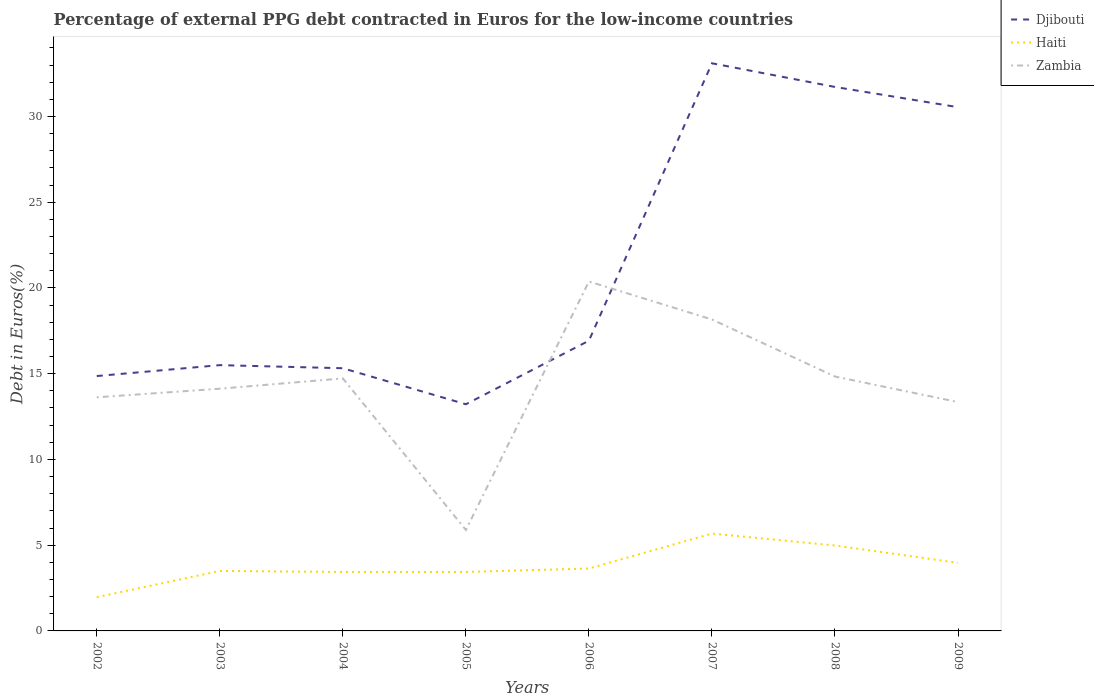How many different coloured lines are there?
Give a very brief answer. 3. Does the line corresponding to Haiti intersect with the line corresponding to Djibouti?
Give a very brief answer. No. Across all years, what is the maximum percentage of external PPG debt contracted in Euros in Zambia?
Keep it short and to the point. 5.89. In which year was the percentage of external PPG debt contracted in Euros in Djibouti maximum?
Give a very brief answer. 2005. What is the total percentage of external PPG debt contracted in Euros in Haiti in the graph?
Make the answer very short. -1.34. What is the difference between the highest and the second highest percentage of external PPG debt contracted in Euros in Djibouti?
Offer a terse response. 19.88. What is the difference between the highest and the lowest percentage of external PPG debt contracted in Euros in Haiti?
Make the answer very short. 3. Is the percentage of external PPG debt contracted in Euros in Haiti strictly greater than the percentage of external PPG debt contracted in Euros in Zambia over the years?
Provide a short and direct response. Yes. How many lines are there?
Provide a succinct answer. 3. How many years are there in the graph?
Keep it short and to the point. 8. Are the values on the major ticks of Y-axis written in scientific E-notation?
Make the answer very short. No. What is the title of the graph?
Keep it short and to the point. Percentage of external PPG debt contracted in Euros for the low-income countries. Does "West Bank and Gaza" appear as one of the legend labels in the graph?
Keep it short and to the point. No. What is the label or title of the Y-axis?
Keep it short and to the point. Debt in Euros(%). What is the Debt in Euros(%) of Djibouti in 2002?
Give a very brief answer. 14.86. What is the Debt in Euros(%) in Haiti in 2002?
Keep it short and to the point. 1.97. What is the Debt in Euros(%) in Zambia in 2002?
Offer a very short reply. 13.62. What is the Debt in Euros(%) of Djibouti in 2003?
Your response must be concise. 15.5. What is the Debt in Euros(%) of Haiti in 2003?
Ensure brevity in your answer.  3.5. What is the Debt in Euros(%) of Zambia in 2003?
Provide a succinct answer. 14.12. What is the Debt in Euros(%) of Djibouti in 2004?
Offer a terse response. 15.32. What is the Debt in Euros(%) of Haiti in 2004?
Your answer should be compact. 3.44. What is the Debt in Euros(%) in Zambia in 2004?
Make the answer very short. 14.72. What is the Debt in Euros(%) in Djibouti in 2005?
Your response must be concise. 13.22. What is the Debt in Euros(%) in Haiti in 2005?
Keep it short and to the point. 3.44. What is the Debt in Euros(%) in Zambia in 2005?
Make the answer very short. 5.89. What is the Debt in Euros(%) in Djibouti in 2006?
Provide a succinct answer. 16.92. What is the Debt in Euros(%) in Haiti in 2006?
Ensure brevity in your answer.  3.64. What is the Debt in Euros(%) of Zambia in 2006?
Your answer should be very brief. 20.38. What is the Debt in Euros(%) of Djibouti in 2007?
Offer a very short reply. 33.1. What is the Debt in Euros(%) of Haiti in 2007?
Your answer should be compact. 5.68. What is the Debt in Euros(%) in Zambia in 2007?
Provide a short and direct response. 18.16. What is the Debt in Euros(%) of Djibouti in 2008?
Your response must be concise. 31.72. What is the Debt in Euros(%) of Haiti in 2008?
Keep it short and to the point. 4.98. What is the Debt in Euros(%) of Zambia in 2008?
Your answer should be very brief. 14.83. What is the Debt in Euros(%) of Djibouti in 2009?
Your answer should be very brief. 30.54. What is the Debt in Euros(%) in Haiti in 2009?
Keep it short and to the point. 3.97. What is the Debt in Euros(%) in Zambia in 2009?
Offer a very short reply. 13.35. Across all years, what is the maximum Debt in Euros(%) in Djibouti?
Provide a succinct answer. 33.1. Across all years, what is the maximum Debt in Euros(%) in Haiti?
Offer a very short reply. 5.68. Across all years, what is the maximum Debt in Euros(%) of Zambia?
Offer a terse response. 20.38. Across all years, what is the minimum Debt in Euros(%) in Djibouti?
Make the answer very short. 13.22. Across all years, what is the minimum Debt in Euros(%) of Haiti?
Offer a terse response. 1.97. Across all years, what is the minimum Debt in Euros(%) of Zambia?
Provide a succinct answer. 5.89. What is the total Debt in Euros(%) of Djibouti in the graph?
Ensure brevity in your answer.  171.18. What is the total Debt in Euros(%) in Haiti in the graph?
Your answer should be very brief. 30.61. What is the total Debt in Euros(%) in Zambia in the graph?
Offer a very short reply. 115.07. What is the difference between the Debt in Euros(%) in Djibouti in 2002 and that in 2003?
Ensure brevity in your answer.  -0.64. What is the difference between the Debt in Euros(%) in Haiti in 2002 and that in 2003?
Provide a short and direct response. -1.53. What is the difference between the Debt in Euros(%) in Zambia in 2002 and that in 2003?
Make the answer very short. -0.5. What is the difference between the Debt in Euros(%) of Djibouti in 2002 and that in 2004?
Your answer should be very brief. -0.46. What is the difference between the Debt in Euros(%) of Haiti in 2002 and that in 2004?
Offer a very short reply. -1.47. What is the difference between the Debt in Euros(%) in Zambia in 2002 and that in 2004?
Make the answer very short. -1.1. What is the difference between the Debt in Euros(%) of Djibouti in 2002 and that in 2005?
Your answer should be very brief. 1.64. What is the difference between the Debt in Euros(%) in Haiti in 2002 and that in 2005?
Ensure brevity in your answer.  -1.47. What is the difference between the Debt in Euros(%) of Zambia in 2002 and that in 2005?
Keep it short and to the point. 7.73. What is the difference between the Debt in Euros(%) in Djibouti in 2002 and that in 2006?
Offer a very short reply. -2.06. What is the difference between the Debt in Euros(%) of Haiti in 2002 and that in 2006?
Ensure brevity in your answer.  -1.67. What is the difference between the Debt in Euros(%) in Zambia in 2002 and that in 2006?
Give a very brief answer. -6.75. What is the difference between the Debt in Euros(%) in Djibouti in 2002 and that in 2007?
Make the answer very short. -18.24. What is the difference between the Debt in Euros(%) of Haiti in 2002 and that in 2007?
Keep it short and to the point. -3.71. What is the difference between the Debt in Euros(%) in Zambia in 2002 and that in 2007?
Ensure brevity in your answer.  -4.54. What is the difference between the Debt in Euros(%) of Djibouti in 2002 and that in 2008?
Ensure brevity in your answer.  -16.86. What is the difference between the Debt in Euros(%) of Haiti in 2002 and that in 2008?
Keep it short and to the point. -3.02. What is the difference between the Debt in Euros(%) in Zambia in 2002 and that in 2008?
Your answer should be compact. -1.21. What is the difference between the Debt in Euros(%) in Djibouti in 2002 and that in 2009?
Provide a short and direct response. -15.68. What is the difference between the Debt in Euros(%) of Haiti in 2002 and that in 2009?
Ensure brevity in your answer.  -2. What is the difference between the Debt in Euros(%) of Zambia in 2002 and that in 2009?
Provide a succinct answer. 0.28. What is the difference between the Debt in Euros(%) of Djibouti in 2003 and that in 2004?
Offer a very short reply. 0.18. What is the difference between the Debt in Euros(%) in Haiti in 2003 and that in 2004?
Make the answer very short. 0.06. What is the difference between the Debt in Euros(%) in Zambia in 2003 and that in 2004?
Offer a terse response. -0.6. What is the difference between the Debt in Euros(%) in Djibouti in 2003 and that in 2005?
Keep it short and to the point. 2.28. What is the difference between the Debt in Euros(%) in Haiti in 2003 and that in 2005?
Offer a terse response. 0.06. What is the difference between the Debt in Euros(%) of Zambia in 2003 and that in 2005?
Offer a terse response. 8.24. What is the difference between the Debt in Euros(%) in Djibouti in 2003 and that in 2006?
Give a very brief answer. -1.43. What is the difference between the Debt in Euros(%) of Haiti in 2003 and that in 2006?
Your response must be concise. -0.14. What is the difference between the Debt in Euros(%) in Zambia in 2003 and that in 2006?
Your response must be concise. -6.25. What is the difference between the Debt in Euros(%) in Djibouti in 2003 and that in 2007?
Ensure brevity in your answer.  -17.6. What is the difference between the Debt in Euros(%) of Haiti in 2003 and that in 2007?
Offer a very short reply. -2.18. What is the difference between the Debt in Euros(%) of Zambia in 2003 and that in 2007?
Provide a succinct answer. -4.04. What is the difference between the Debt in Euros(%) of Djibouti in 2003 and that in 2008?
Your answer should be compact. -16.22. What is the difference between the Debt in Euros(%) in Haiti in 2003 and that in 2008?
Your answer should be compact. -1.49. What is the difference between the Debt in Euros(%) of Zambia in 2003 and that in 2008?
Your answer should be very brief. -0.71. What is the difference between the Debt in Euros(%) of Djibouti in 2003 and that in 2009?
Provide a succinct answer. -15.04. What is the difference between the Debt in Euros(%) of Haiti in 2003 and that in 2009?
Your response must be concise. -0.47. What is the difference between the Debt in Euros(%) of Zambia in 2003 and that in 2009?
Ensure brevity in your answer.  0.78. What is the difference between the Debt in Euros(%) in Djibouti in 2004 and that in 2005?
Provide a short and direct response. 2.1. What is the difference between the Debt in Euros(%) of Zambia in 2004 and that in 2005?
Make the answer very short. 8.84. What is the difference between the Debt in Euros(%) of Djibouti in 2004 and that in 2006?
Provide a succinct answer. -1.61. What is the difference between the Debt in Euros(%) in Haiti in 2004 and that in 2006?
Offer a terse response. -0.2. What is the difference between the Debt in Euros(%) in Zambia in 2004 and that in 2006?
Make the answer very short. -5.65. What is the difference between the Debt in Euros(%) of Djibouti in 2004 and that in 2007?
Give a very brief answer. -17.78. What is the difference between the Debt in Euros(%) of Haiti in 2004 and that in 2007?
Provide a succinct answer. -2.24. What is the difference between the Debt in Euros(%) in Zambia in 2004 and that in 2007?
Your answer should be very brief. -3.44. What is the difference between the Debt in Euros(%) in Djibouti in 2004 and that in 2008?
Your answer should be very brief. -16.4. What is the difference between the Debt in Euros(%) in Haiti in 2004 and that in 2008?
Keep it short and to the point. -1.54. What is the difference between the Debt in Euros(%) of Zambia in 2004 and that in 2008?
Keep it short and to the point. -0.11. What is the difference between the Debt in Euros(%) in Djibouti in 2004 and that in 2009?
Your response must be concise. -15.22. What is the difference between the Debt in Euros(%) of Haiti in 2004 and that in 2009?
Your response must be concise. -0.53. What is the difference between the Debt in Euros(%) of Zambia in 2004 and that in 2009?
Make the answer very short. 1.38. What is the difference between the Debt in Euros(%) in Djibouti in 2005 and that in 2006?
Provide a succinct answer. -3.71. What is the difference between the Debt in Euros(%) of Haiti in 2005 and that in 2006?
Ensure brevity in your answer.  -0.2. What is the difference between the Debt in Euros(%) of Zambia in 2005 and that in 2006?
Give a very brief answer. -14.49. What is the difference between the Debt in Euros(%) of Djibouti in 2005 and that in 2007?
Offer a very short reply. -19.88. What is the difference between the Debt in Euros(%) of Haiti in 2005 and that in 2007?
Your answer should be very brief. -2.24. What is the difference between the Debt in Euros(%) in Zambia in 2005 and that in 2007?
Offer a very short reply. -12.27. What is the difference between the Debt in Euros(%) in Djibouti in 2005 and that in 2008?
Provide a succinct answer. -18.5. What is the difference between the Debt in Euros(%) in Haiti in 2005 and that in 2008?
Your response must be concise. -1.54. What is the difference between the Debt in Euros(%) of Zambia in 2005 and that in 2008?
Offer a very short reply. -8.95. What is the difference between the Debt in Euros(%) of Djibouti in 2005 and that in 2009?
Provide a succinct answer. -17.32. What is the difference between the Debt in Euros(%) of Haiti in 2005 and that in 2009?
Provide a short and direct response. -0.53. What is the difference between the Debt in Euros(%) in Zambia in 2005 and that in 2009?
Keep it short and to the point. -7.46. What is the difference between the Debt in Euros(%) of Djibouti in 2006 and that in 2007?
Provide a succinct answer. -16.18. What is the difference between the Debt in Euros(%) of Haiti in 2006 and that in 2007?
Offer a terse response. -2.04. What is the difference between the Debt in Euros(%) in Zambia in 2006 and that in 2007?
Keep it short and to the point. 2.21. What is the difference between the Debt in Euros(%) in Djibouti in 2006 and that in 2008?
Your answer should be compact. -14.8. What is the difference between the Debt in Euros(%) in Haiti in 2006 and that in 2008?
Provide a succinct answer. -1.34. What is the difference between the Debt in Euros(%) of Zambia in 2006 and that in 2008?
Ensure brevity in your answer.  5.54. What is the difference between the Debt in Euros(%) in Djibouti in 2006 and that in 2009?
Make the answer very short. -13.62. What is the difference between the Debt in Euros(%) in Haiti in 2006 and that in 2009?
Give a very brief answer. -0.33. What is the difference between the Debt in Euros(%) of Zambia in 2006 and that in 2009?
Your response must be concise. 7.03. What is the difference between the Debt in Euros(%) in Djibouti in 2007 and that in 2008?
Your response must be concise. 1.38. What is the difference between the Debt in Euros(%) in Haiti in 2007 and that in 2008?
Offer a terse response. 0.69. What is the difference between the Debt in Euros(%) in Zambia in 2007 and that in 2008?
Ensure brevity in your answer.  3.33. What is the difference between the Debt in Euros(%) of Djibouti in 2007 and that in 2009?
Give a very brief answer. 2.56. What is the difference between the Debt in Euros(%) in Haiti in 2007 and that in 2009?
Your answer should be compact. 1.71. What is the difference between the Debt in Euros(%) in Zambia in 2007 and that in 2009?
Provide a succinct answer. 4.82. What is the difference between the Debt in Euros(%) of Djibouti in 2008 and that in 2009?
Offer a terse response. 1.18. What is the difference between the Debt in Euros(%) of Haiti in 2008 and that in 2009?
Keep it short and to the point. 1.01. What is the difference between the Debt in Euros(%) of Zambia in 2008 and that in 2009?
Provide a short and direct response. 1.49. What is the difference between the Debt in Euros(%) in Djibouti in 2002 and the Debt in Euros(%) in Haiti in 2003?
Provide a short and direct response. 11.37. What is the difference between the Debt in Euros(%) of Djibouti in 2002 and the Debt in Euros(%) of Zambia in 2003?
Make the answer very short. 0.74. What is the difference between the Debt in Euros(%) of Haiti in 2002 and the Debt in Euros(%) of Zambia in 2003?
Make the answer very short. -12.16. What is the difference between the Debt in Euros(%) in Djibouti in 2002 and the Debt in Euros(%) in Haiti in 2004?
Provide a succinct answer. 11.42. What is the difference between the Debt in Euros(%) in Djibouti in 2002 and the Debt in Euros(%) in Zambia in 2004?
Keep it short and to the point. 0.14. What is the difference between the Debt in Euros(%) in Haiti in 2002 and the Debt in Euros(%) in Zambia in 2004?
Offer a very short reply. -12.76. What is the difference between the Debt in Euros(%) of Djibouti in 2002 and the Debt in Euros(%) of Haiti in 2005?
Your answer should be compact. 11.42. What is the difference between the Debt in Euros(%) of Djibouti in 2002 and the Debt in Euros(%) of Zambia in 2005?
Your response must be concise. 8.97. What is the difference between the Debt in Euros(%) in Haiti in 2002 and the Debt in Euros(%) in Zambia in 2005?
Offer a terse response. -3.92. What is the difference between the Debt in Euros(%) of Djibouti in 2002 and the Debt in Euros(%) of Haiti in 2006?
Your response must be concise. 11.22. What is the difference between the Debt in Euros(%) in Djibouti in 2002 and the Debt in Euros(%) in Zambia in 2006?
Provide a short and direct response. -5.51. What is the difference between the Debt in Euros(%) of Haiti in 2002 and the Debt in Euros(%) of Zambia in 2006?
Offer a terse response. -18.41. What is the difference between the Debt in Euros(%) in Djibouti in 2002 and the Debt in Euros(%) in Haiti in 2007?
Offer a very short reply. 9.19. What is the difference between the Debt in Euros(%) of Djibouti in 2002 and the Debt in Euros(%) of Zambia in 2007?
Your answer should be compact. -3.3. What is the difference between the Debt in Euros(%) of Haiti in 2002 and the Debt in Euros(%) of Zambia in 2007?
Your answer should be compact. -16.19. What is the difference between the Debt in Euros(%) of Djibouti in 2002 and the Debt in Euros(%) of Haiti in 2008?
Give a very brief answer. 9.88. What is the difference between the Debt in Euros(%) of Djibouti in 2002 and the Debt in Euros(%) of Zambia in 2008?
Your answer should be very brief. 0.03. What is the difference between the Debt in Euros(%) of Haiti in 2002 and the Debt in Euros(%) of Zambia in 2008?
Ensure brevity in your answer.  -12.87. What is the difference between the Debt in Euros(%) in Djibouti in 2002 and the Debt in Euros(%) in Haiti in 2009?
Keep it short and to the point. 10.89. What is the difference between the Debt in Euros(%) in Djibouti in 2002 and the Debt in Euros(%) in Zambia in 2009?
Provide a succinct answer. 1.52. What is the difference between the Debt in Euros(%) of Haiti in 2002 and the Debt in Euros(%) of Zambia in 2009?
Ensure brevity in your answer.  -11.38. What is the difference between the Debt in Euros(%) in Djibouti in 2003 and the Debt in Euros(%) in Haiti in 2004?
Your answer should be compact. 12.06. What is the difference between the Debt in Euros(%) of Djibouti in 2003 and the Debt in Euros(%) of Zambia in 2004?
Make the answer very short. 0.77. What is the difference between the Debt in Euros(%) of Haiti in 2003 and the Debt in Euros(%) of Zambia in 2004?
Ensure brevity in your answer.  -11.23. What is the difference between the Debt in Euros(%) in Djibouti in 2003 and the Debt in Euros(%) in Haiti in 2005?
Keep it short and to the point. 12.06. What is the difference between the Debt in Euros(%) in Djibouti in 2003 and the Debt in Euros(%) in Zambia in 2005?
Provide a succinct answer. 9.61. What is the difference between the Debt in Euros(%) of Haiti in 2003 and the Debt in Euros(%) of Zambia in 2005?
Your answer should be compact. -2.39. What is the difference between the Debt in Euros(%) of Djibouti in 2003 and the Debt in Euros(%) of Haiti in 2006?
Provide a succinct answer. 11.86. What is the difference between the Debt in Euros(%) of Djibouti in 2003 and the Debt in Euros(%) of Zambia in 2006?
Provide a short and direct response. -4.88. What is the difference between the Debt in Euros(%) of Haiti in 2003 and the Debt in Euros(%) of Zambia in 2006?
Your answer should be very brief. -16.88. What is the difference between the Debt in Euros(%) of Djibouti in 2003 and the Debt in Euros(%) of Haiti in 2007?
Your response must be concise. 9.82. What is the difference between the Debt in Euros(%) of Djibouti in 2003 and the Debt in Euros(%) of Zambia in 2007?
Offer a very short reply. -2.66. What is the difference between the Debt in Euros(%) in Haiti in 2003 and the Debt in Euros(%) in Zambia in 2007?
Offer a very short reply. -14.66. What is the difference between the Debt in Euros(%) in Djibouti in 2003 and the Debt in Euros(%) in Haiti in 2008?
Give a very brief answer. 10.52. What is the difference between the Debt in Euros(%) of Djibouti in 2003 and the Debt in Euros(%) of Zambia in 2008?
Ensure brevity in your answer.  0.67. What is the difference between the Debt in Euros(%) in Haiti in 2003 and the Debt in Euros(%) in Zambia in 2008?
Make the answer very short. -11.34. What is the difference between the Debt in Euros(%) of Djibouti in 2003 and the Debt in Euros(%) of Haiti in 2009?
Keep it short and to the point. 11.53. What is the difference between the Debt in Euros(%) in Djibouti in 2003 and the Debt in Euros(%) in Zambia in 2009?
Offer a very short reply. 2.15. What is the difference between the Debt in Euros(%) in Haiti in 2003 and the Debt in Euros(%) in Zambia in 2009?
Your response must be concise. -9.85. What is the difference between the Debt in Euros(%) in Djibouti in 2004 and the Debt in Euros(%) in Haiti in 2005?
Offer a terse response. 11.88. What is the difference between the Debt in Euros(%) of Djibouti in 2004 and the Debt in Euros(%) of Zambia in 2005?
Give a very brief answer. 9.43. What is the difference between the Debt in Euros(%) of Haiti in 2004 and the Debt in Euros(%) of Zambia in 2005?
Ensure brevity in your answer.  -2.45. What is the difference between the Debt in Euros(%) in Djibouti in 2004 and the Debt in Euros(%) in Haiti in 2006?
Your response must be concise. 11.68. What is the difference between the Debt in Euros(%) in Djibouti in 2004 and the Debt in Euros(%) in Zambia in 2006?
Offer a very short reply. -5.06. What is the difference between the Debt in Euros(%) in Haiti in 2004 and the Debt in Euros(%) in Zambia in 2006?
Keep it short and to the point. -16.94. What is the difference between the Debt in Euros(%) in Djibouti in 2004 and the Debt in Euros(%) in Haiti in 2007?
Offer a very short reply. 9.64. What is the difference between the Debt in Euros(%) in Djibouti in 2004 and the Debt in Euros(%) in Zambia in 2007?
Provide a succinct answer. -2.84. What is the difference between the Debt in Euros(%) in Haiti in 2004 and the Debt in Euros(%) in Zambia in 2007?
Provide a short and direct response. -14.72. What is the difference between the Debt in Euros(%) of Djibouti in 2004 and the Debt in Euros(%) of Haiti in 2008?
Give a very brief answer. 10.34. What is the difference between the Debt in Euros(%) in Djibouti in 2004 and the Debt in Euros(%) in Zambia in 2008?
Provide a short and direct response. 0.48. What is the difference between the Debt in Euros(%) in Haiti in 2004 and the Debt in Euros(%) in Zambia in 2008?
Provide a succinct answer. -11.4. What is the difference between the Debt in Euros(%) in Djibouti in 2004 and the Debt in Euros(%) in Haiti in 2009?
Give a very brief answer. 11.35. What is the difference between the Debt in Euros(%) in Djibouti in 2004 and the Debt in Euros(%) in Zambia in 2009?
Offer a terse response. 1.97. What is the difference between the Debt in Euros(%) in Haiti in 2004 and the Debt in Euros(%) in Zambia in 2009?
Your answer should be very brief. -9.91. What is the difference between the Debt in Euros(%) in Djibouti in 2005 and the Debt in Euros(%) in Haiti in 2006?
Offer a terse response. 9.58. What is the difference between the Debt in Euros(%) in Djibouti in 2005 and the Debt in Euros(%) in Zambia in 2006?
Your answer should be very brief. -7.16. What is the difference between the Debt in Euros(%) of Haiti in 2005 and the Debt in Euros(%) of Zambia in 2006?
Your response must be concise. -16.94. What is the difference between the Debt in Euros(%) of Djibouti in 2005 and the Debt in Euros(%) of Haiti in 2007?
Your response must be concise. 7.54. What is the difference between the Debt in Euros(%) of Djibouti in 2005 and the Debt in Euros(%) of Zambia in 2007?
Provide a short and direct response. -4.94. What is the difference between the Debt in Euros(%) of Haiti in 2005 and the Debt in Euros(%) of Zambia in 2007?
Your response must be concise. -14.72. What is the difference between the Debt in Euros(%) of Djibouti in 2005 and the Debt in Euros(%) of Haiti in 2008?
Your answer should be very brief. 8.23. What is the difference between the Debt in Euros(%) in Djibouti in 2005 and the Debt in Euros(%) in Zambia in 2008?
Offer a terse response. -1.62. What is the difference between the Debt in Euros(%) in Haiti in 2005 and the Debt in Euros(%) in Zambia in 2008?
Give a very brief answer. -11.4. What is the difference between the Debt in Euros(%) in Djibouti in 2005 and the Debt in Euros(%) in Haiti in 2009?
Give a very brief answer. 9.25. What is the difference between the Debt in Euros(%) in Djibouti in 2005 and the Debt in Euros(%) in Zambia in 2009?
Make the answer very short. -0.13. What is the difference between the Debt in Euros(%) of Haiti in 2005 and the Debt in Euros(%) of Zambia in 2009?
Your response must be concise. -9.91. What is the difference between the Debt in Euros(%) in Djibouti in 2006 and the Debt in Euros(%) in Haiti in 2007?
Offer a terse response. 11.25. What is the difference between the Debt in Euros(%) in Djibouti in 2006 and the Debt in Euros(%) in Zambia in 2007?
Offer a very short reply. -1.24. What is the difference between the Debt in Euros(%) of Haiti in 2006 and the Debt in Euros(%) of Zambia in 2007?
Give a very brief answer. -14.52. What is the difference between the Debt in Euros(%) in Djibouti in 2006 and the Debt in Euros(%) in Haiti in 2008?
Give a very brief answer. 11.94. What is the difference between the Debt in Euros(%) of Djibouti in 2006 and the Debt in Euros(%) of Zambia in 2008?
Make the answer very short. 2.09. What is the difference between the Debt in Euros(%) in Haiti in 2006 and the Debt in Euros(%) in Zambia in 2008?
Provide a succinct answer. -11.19. What is the difference between the Debt in Euros(%) of Djibouti in 2006 and the Debt in Euros(%) of Haiti in 2009?
Your response must be concise. 12.96. What is the difference between the Debt in Euros(%) in Djibouti in 2006 and the Debt in Euros(%) in Zambia in 2009?
Give a very brief answer. 3.58. What is the difference between the Debt in Euros(%) of Haiti in 2006 and the Debt in Euros(%) of Zambia in 2009?
Make the answer very short. -9.71. What is the difference between the Debt in Euros(%) of Djibouti in 2007 and the Debt in Euros(%) of Haiti in 2008?
Provide a succinct answer. 28.12. What is the difference between the Debt in Euros(%) in Djibouti in 2007 and the Debt in Euros(%) in Zambia in 2008?
Your answer should be very brief. 18.27. What is the difference between the Debt in Euros(%) in Haiti in 2007 and the Debt in Euros(%) in Zambia in 2008?
Give a very brief answer. -9.16. What is the difference between the Debt in Euros(%) in Djibouti in 2007 and the Debt in Euros(%) in Haiti in 2009?
Provide a short and direct response. 29.13. What is the difference between the Debt in Euros(%) of Djibouti in 2007 and the Debt in Euros(%) of Zambia in 2009?
Keep it short and to the point. 19.76. What is the difference between the Debt in Euros(%) in Haiti in 2007 and the Debt in Euros(%) in Zambia in 2009?
Your answer should be very brief. -7.67. What is the difference between the Debt in Euros(%) of Djibouti in 2008 and the Debt in Euros(%) of Haiti in 2009?
Ensure brevity in your answer.  27.75. What is the difference between the Debt in Euros(%) of Djibouti in 2008 and the Debt in Euros(%) of Zambia in 2009?
Provide a short and direct response. 18.38. What is the difference between the Debt in Euros(%) in Haiti in 2008 and the Debt in Euros(%) in Zambia in 2009?
Offer a terse response. -8.36. What is the average Debt in Euros(%) of Djibouti per year?
Keep it short and to the point. 21.4. What is the average Debt in Euros(%) of Haiti per year?
Ensure brevity in your answer.  3.83. What is the average Debt in Euros(%) in Zambia per year?
Your answer should be very brief. 14.38. In the year 2002, what is the difference between the Debt in Euros(%) in Djibouti and Debt in Euros(%) in Haiti?
Make the answer very short. 12.9. In the year 2002, what is the difference between the Debt in Euros(%) of Djibouti and Debt in Euros(%) of Zambia?
Your answer should be very brief. 1.24. In the year 2002, what is the difference between the Debt in Euros(%) of Haiti and Debt in Euros(%) of Zambia?
Your answer should be very brief. -11.66. In the year 2003, what is the difference between the Debt in Euros(%) in Djibouti and Debt in Euros(%) in Haiti?
Your answer should be compact. 12. In the year 2003, what is the difference between the Debt in Euros(%) of Djibouti and Debt in Euros(%) of Zambia?
Ensure brevity in your answer.  1.37. In the year 2003, what is the difference between the Debt in Euros(%) of Haiti and Debt in Euros(%) of Zambia?
Offer a terse response. -10.63. In the year 2004, what is the difference between the Debt in Euros(%) in Djibouti and Debt in Euros(%) in Haiti?
Offer a terse response. 11.88. In the year 2004, what is the difference between the Debt in Euros(%) in Djibouti and Debt in Euros(%) in Zambia?
Make the answer very short. 0.59. In the year 2004, what is the difference between the Debt in Euros(%) of Haiti and Debt in Euros(%) of Zambia?
Offer a terse response. -11.29. In the year 2005, what is the difference between the Debt in Euros(%) of Djibouti and Debt in Euros(%) of Haiti?
Your answer should be very brief. 9.78. In the year 2005, what is the difference between the Debt in Euros(%) in Djibouti and Debt in Euros(%) in Zambia?
Your answer should be compact. 7.33. In the year 2005, what is the difference between the Debt in Euros(%) of Haiti and Debt in Euros(%) of Zambia?
Your answer should be very brief. -2.45. In the year 2006, what is the difference between the Debt in Euros(%) of Djibouti and Debt in Euros(%) of Haiti?
Your answer should be very brief. 13.28. In the year 2006, what is the difference between the Debt in Euros(%) in Djibouti and Debt in Euros(%) in Zambia?
Your answer should be compact. -3.45. In the year 2006, what is the difference between the Debt in Euros(%) of Haiti and Debt in Euros(%) of Zambia?
Provide a short and direct response. -16.74. In the year 2007, what is the difference between the Debt in Euros(%) in Djibouti and Debt in Euros(%) in Haiti?
Give a very brief answer. 27.42. In the year 2007, what is the difference between the Debt in Euros(%) in Djibouti and Debt in Euros(%) in Zambia?
Your response must be concise. 14.94. In the year 2007, what is the difference between the Debt in Euros(%) in Haiti and Debt in Euros(%) in Zambia?
Provide a succinct answer. -12.48. In the year 2008, what is the difference between the Debt in Euros(%) in Djibouti and Debt in Euros(%) in Haiti?
Offer a terse response. 26.74. In the year 2008, what is the difference between the Debt in Euros(%) in Djibouti and Debt in Euros(%) in Zambia?
Provide a succinct answer. 16.89. In the year 2008, what is the difference between the Debt in Euros(%) of Haiti and Debt in Euros(%) of Zambia?
Your response must be concise. -9.85. In the year 2009, what is the difference between the Debt in Euros(%) of Djibouti and Debt in Euros(%) of Haiti?
Give a very brief answer. 26.57. In the year 2009, what is the difference between the Debt in Euros(%) of Djibouti and Debt in Euros(%) of Zambia?
Offer a terse response. 17.19. In the year 2009, what is the difference between the Debt in Euros(%) of Haiti and Debt in Euros(%) of Zambia?
Offer a terse response. -9.38. What is the ratio of the Debt in Euros(%) in Djibouti in 2002 to that in 2003?
Make the answer very short. 0.96. What is the ratio of the Debt in Euros(%) of Haiti in 2002 to that in 2003?
Offer a very short reply. 0.56. What is the ratio of the Debt in Euros(%) of Zambia in 2002 to that in 2003?
Your answer should be very brief. 0.96. What is the ratio of the Debt in Euros(%) of Djibouti in 2002 to that in 2004?
Make the answer very short. 0.97. What is the ratio of the Debt in Euros(%) in Haiti in 2002 to that in 2004?
Give a very brief answer. 0.57. What is the ratio of the Debt in Euros(%) in Zambia in 2002 to that in 2004?
Your response must be concise. 0.93. What is the ratio of the Debt in Euros(%) of Djibouti in 2002 to that in 2005?
Offer a very short reply. 1.12. What is the ratio of the Debt in Euros(%) in Haiti in 2002 to that in 2005?
Provide a short and direct response. 0.57. What is the ratio of the Debt in Euros(%) of Zambia in 2002 to that in 2005?
Provide a short and direct response. 2.31. What is the ratio of the Debt in Euros(%) of Djibouti in 2002 to that in 2006?
Offer a very short reply. 0.88. What is the ratio of the Debt in Euros(%) in Haiti in 2002 to that in 2006?
Offer a terse response. 0.54. What is the ratio of the Debt in Euros(%) of Zambia in 2002 to that in 2006?
Ensure brevity in your answer.  0.67. What is the ratio of the Debt in Euros(%) in Djibouti in 2002 to that in 2007?
Give a very brief answer. 0.45. What is the ratio of the Debt in Euros(%) in Haiti in 2002 to that in 2007?
Make the answer very short. 0.35. What is the ratio of the Debt in Euros(%) of Zambia in 2002 to that in 2007?
Make the answer very short. 0.75. What is the ratio of the Debt in Euros(%) in Djibouti in 2002 to that in 2008?
Provide a short and direct response. 0.47. What is the ratio of the Debt in Euros(%) in Haiti in 2002 to that in 2008?
Keep it short and to the point. 0.39. What is the ratio of the Debt in Euros(%) of Zambia in 2002 to that in 2008?
Keep it short and to the point. 0.92. What is the ratio of the Debt in Euros(%) of Djibouti in 2002 to that in 2009?
Your answer should be compact. 0.49. What is the ratio of the Debt in Euros(%) of Haiti in 2002 to that in 2009?
Provide a succinct answer. 0.5. What is the ratio of the Debt in Euros(%) in Zambia in 2002 to that in 2009?
Offer a very short reply. 1.02. What is the ratio of the Debt in Euros(%) in Djibouti in 2003 to that in 2004?
Your response must be concise. 1.01. What is the ratio of the Debt in Euros(%) in Haiti in 2003 to that in 2004?
Keep it short and to the point. 1.02. What is the ratio of the Debt in Euros(%) in Zambia in 2003 to that in 2004?
Your response must be concise. 0.96. What is the ratio of the Debt in Euros(%) of Djibouti in 2003 to that in 2005?
Ensure brevity in your answer.  1.17. What is the ratio of the Debt in Euros(%) in Haiti in 2003 to that in 2005?
Provide a short and direct response. 1.02. What is the ratio of the Debt in Euros(%) of Zambia in 2003 to that in 2005?
Keep it short and to the point. 2.4. What is the ratio of the Debt in Euros(%) in Djibouti in 2003 to that in 2006?
Provide a succinct answer. 0.92. What is the ratio of the Debt in Euros(%) of Haiti in 2003 to that in 2006?
Provide a succinct answer. 0.96. What is the ratio of the Debt in Euros(%) of Zambia in 2003 to that in 2006?
Your response must be concise. 0.69. What is the ratio of the Debt in Euros(%) of Djibouti in 2003 to that in 2007?
Provide a succinct answer. 0.47. What is the ratio of the Debt in Euros(%) of Haiti in 2003 to that in 2007?
Keep it short and to the point. 0.62. What is the ratio of the Debt in Euros(%) of Zambia in 2003 to that in 2007?
Make the answer very short. 0.78. What is the ratio of the Debt in Euros(%) in Djibouti in 2003 to that in 2008?
Your answer should be very brief. 0.49. What is the ratio of the Debt in Euros(%) in Haiti in 2003 to that in 2008?
Give a very brief answer. 0.7. What is the ratio of the Debt in Euros(%) of Zambia in 2003 to that in 2008?
Give a very brief answer. 0.95. What is the ratio of the Debt in Euros(%) of Djibouti in 2003 to that in 2009?
Your response must be concise. 0.51. What is the ratio of the Debt in Euros(%) of Haiti in 2003 to that in 2009?
Your answer should be compact. 0.88. What is the ratio of the Debt in Euros(%) in Zambia in 2003 to that in 2009?
Offer a very short reply. 1.06. What is the ratio of the Debt in Euros(%) of Djibouti in 2004 to that in 2005?
Ensure brevity in your answer.  1.16. What is the ratio of the Debt in Euros(%) of Zambia in 2004 to that in 2005?
Your answer should be very brief. 2.5. What is the ratio of the Debt in Euros(%) of Djibouti in 2004 to that in 2006?
Give a very brief answer. 0.91. What is the ratio of the Debt in Euros(%) of Haiti in 2004 to that in 2006?
Offer a very short reply. 0.94. What is the ratio of the Debt in Euros(%) of Zambia in 2004 to that in 2006?
Your answer should be compact. 0.72. What is the ratio of the Debt in Euros(%) of Djibouti in 2004 to that in 2007?
Give a very brief answer. 0.46. What is the ratio of the Debt in Euros(%) of Haiti in 2004 to that in 2007?
Your response must be concise. 0.61. What is the ratio of the Debt in Euros(%) in Zambia in 2004 to that in 2007?
Provide a short and direct response. 0.81. What is the ratio of the Debt in Euros(%) of Djibouti in 2004 to that in 2008?
Ensure brevity in your answer.  0.48. What is the ratio of the Debt in Euros(%) in Haiti in 2004 to that in 2008?
Offer a very short reply. 0.69. What is the ratio of the Debt in Euros(%) in Zambia in 2004 to that in 2008?
Provide a succinct answer. 0.99. What is the ratio of the Debt in Euros(%) in Djibouti in 2004 to that in 2009?
Your answer should be very brief. 0.5. What is the ratio of the Debt in Euros(%) of Haiti in 2004 to that in 2009?
Keep it short and to the point. 0.87. What is the ratio of the Debt in Euros(%) of Zambia in 2004 to that in 2009?
Your answer should be very brief. 1.1. What is the ratio of the Debt in Euros(%) of Djibouti in 2005 to that in 2006?
Give a very brief answer. 0.78. What is the ratio of the Debt in Euros(%) of Haiti in 2005 to that in 2006?
Your answer should be compact. 0.94. What is the ratio of the Debt in Euros(%) in Zambia in 2005 to that in 2006?
Keep it short and to the point. 0.29. What is the ratio of the Debt in Euros(%) in Djibouti in 2005 to that in 2007?
Your answer should be very brief. 0.4. What is the ratio of the Debt in Euros(%) of Haiti in 2005 to that in 2007?
Make the answer very short. 0.61. What is the ratio of the Debt in Euros(%) in Zambia in 2005 to that in 2007?
Ensure brevity in your answer.  0.32. What is the ratio of the Debt in Euros(%) of Djibouti in 2005 to that in 2008?
Provide a short and direct response. 0.42. What is the ratio of the Debt in Euros(%) in Haiti in 2005 to that in 2008?
Keep it short and to the point. 0.69. What is the ratio of the Debt in Euros(%) of Zambia in 2005 to that in 2008?
Your answer should be compact. 0.4. What is the ratio of the Debt in Euros(%) in Djibouti in 2005 to that in 2009?
Your answer should be very brief. 0.43. What is the ratio of the Debt in Euros(%) of Haiti in 2005 to that in 2009?
Your response must be concise. 0.87. What is the ratio of the Debt in Euros(%) in Zambia in 2005 to that in 2009?
Offer a terse response. 0.44. What is the ratio of the Debt in Euros(%) of Djibouti in 2006 to that in 2007?
Keep it short and to the point. 0.51. What is the ratio of the Debt in Euros(%) in Haiti in 2006 to that in 2007?
Offer a terse response. 0.64. What is the ratio of the Debt in Euros(%) in Zambia in 2006 to that in 2007?
Keep it short and to the point. 1.12. What is the ratio of the Debt in Euros(%) of Djibouti in 2006 to that in 2008?
Offer a terse response. 0.53. What is the ratio of the Debt in Euros(%) of Haiti in 2006 to that in 2008?
Ensure brevity in your answer.  0.73. What is the ratio of the Debt in Euros(%) of Zambia in 2006 to that in 2008?
Your response must be concise. 1.37. What is the ratio of the Debt in Euros(%) of Djibouti in 2006 to that in 2009?
Give a very brief answer. 0.55. What is the ratio of the Debt in Euros(%) of Haiti in 2006 to that in 2009?
Ensure brevity in your answer.  0.92. What is the ratio of the Debt in Euros(%) in Zambia in 2006 to that in 2009?
Your answer should be compact. 1.53. What is the ratio of the Debt in Euros(%) in Djibouti in 2007 to that in 2008?
Ensure brevity in your answer.  1.04. What is the ratio of the Debt in Euros(%) of Haiti in 2007 to that in 2008?
Make the answer very short. 1.14. What is the ratio of the Debt in Euros(%) in Zambia in 2007 to that in 2008?
Offer a terse response. 1.22. What is the ratio of the Debt in Euros(%) of Djibouti in 2007 to that in 2009?
Keep it short and to the point. 1.08. What is the ratio of the Debt in Euros(%) in Haiti in 2007 to that in 2009?
Keep it short and to the point. 1.43. What is the ratio of the Debt in Euros(%) of Zambia in 2007 to that in 2009?
Keep it short and to the point. 1.36. What is the ratio of the Debt in Euros(%) of Djibouti in 2008 to that in 2009?
Provide a short and direct response. 1.04. What is the ratio of the Debt in Euros(%) of Haiti in 2008 to that in 2009?
Your response must be concise. 1.26. What is the ratio of the Debt in Euros(%) of Zambia in 2008 to that in 2009?
Offer a very short reply. 1.11. What is the difference between the highest and the second highest Debt in Euros(%) of Djibouti?
Your response must be concise. 1.38. What is the difference between the highest and the second highest Debt in Euros(%) in Haiti?
Offer a terse response. 0.69. What is the difference between the highest and the second highest Debt in Euros(%) in Zambia?
Ensure brevity in your answer.  2.21. What is the difference between the highest and the lowest Debt in Euros(%) of Djibouti?
Make the answer very short. 19.88. What is the difference between the highest and the lowest Debt in Euros(%) of Haiti?
Offer a very short reply. 3.71. What is the difference between the highest and the lowest Debt in Euros(%) of Zambia?
Your answer should be very brief. 14.49. 